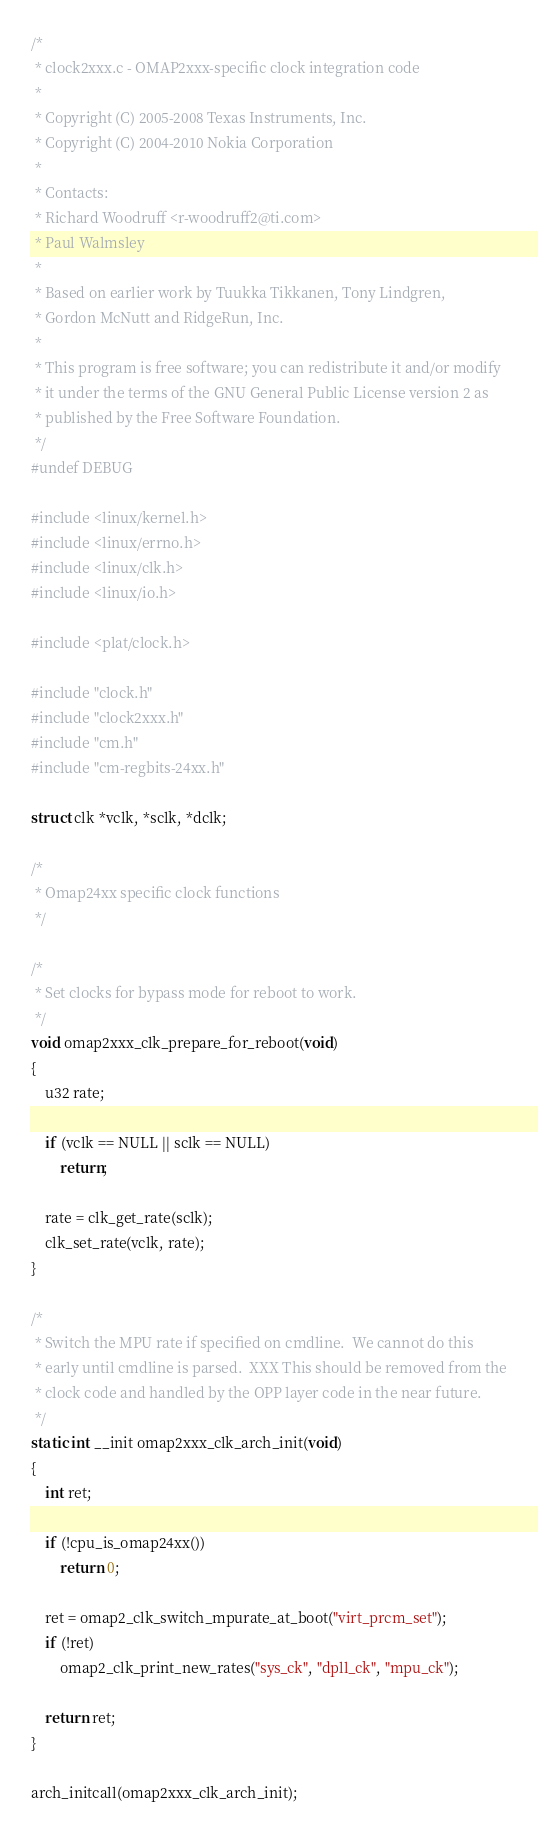<code> <loc_0><loc_0><loc_500><loc_500><_C_>/*
 * clock2xxx.c - OMAP2xxx-specific clock integration code
 *
 * Copyright (C) 2005-2008 Texas Instruments, Inc.
 * Copyright (C) 2004-2010 Nokia Corporation
 *
 * Contacts:
 * Richard Woodruff <r-woodruff2@ti.com>
 * Paul Walmsley
 *
 * Based on earlier work by Tuukka Tikkanen, Tony Lindgren,
 * Gordon McNutt and RidgeRun, Inc.
 *
 * This program is free software; you can redistribute it and/or modify
 * it under the terms of the GNU General Public License version 2 as
 * published by the Free Software Foundation.
 */
#undef DEBUG

#include <linux/kernel.h>
#include <linux/errno.h>
#include <linux/clk.h>
#include <linux/io.h>

#include <plat/clock.h>

#include "clock.h"
#include "clock2xxx.h"
#include "cm.h"
#include "cm-regbits-24xx.h"

struct clk *vclk, *sclk, *dclk;

/*
 * Omap24xx specific clock functions
 */

/*
 * Set clocks for bypass mode for reboot to work.
 */
void omap2xxx_clk_prepare_for_reboot(void)
{
	u32 rate;

	if (vclk == NULL || sclk == NULL)
		return;

	rate = clk_get_rate(sclk);
	clk_set_rate(vclk, rate);
}

/*
 * Switch the MPU rate if specified on cmdline.  We cannot do this
 * early until cmdline is parsed.  XXX This should be removed from the
 * clock code and handled by the OPP layer code in the near future.
 */
static int __init omap2xxx_clk_arch_init(void)
{
	int ret;

	if (!cpu_is_omap24xx())
		return 0;

	ret = omap2_clk_switch_mpurate_at_boot("virt_prcm_set");
	if (!ret)
		omap2_clk_print_new_rates("sys_ck", "dpll_ck", "mpu_ck");

	return ret;
}

arch_initcall(omap2xxx_clk_arch_init);
</code> 